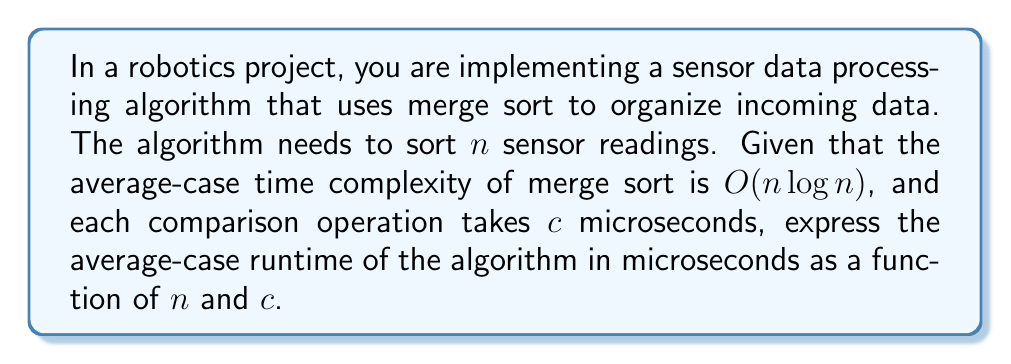Can you answer this question? To solve this problem, we need to follow these steps:

1) Recall that the time complexity $O(n \log n)$ represents the number of comparison operations performed by merge sort in the average case.

2) The actual number of comparisons is approximately $k \cdot n \log n$, where $k$ is a constant factor. For merge sort, $k$ is typically close to 1, so we can assume $k = 1$ for this problem.

3) Each comparison takes $c$ microseconds, so we need to multiply the number of comparisons by $c$.

4) Therefore, the runtime in microseconds can be expressed as:

   $T(n) = c \cdot n \log n$

5) Note that $\log n$ in algorithm analysis typically refers to $\log_2 n$. However, due to the properties of logarithms, we can write this as:

   $T(n) = c \cdot n \ln n / \ln 2$

   where $\ln$ is the natural logarithm.

This formula gives us the average-case runtime of the merge sort algorithm for sorting $n$ sensor readings, where each comparison takes $c$ microseconds.
Answer: $T(n) = c \cdot n \log_2 n$ microseconds, or equivalently, $T(n) = c \cdot n \ln n / \ln 2$ microseconds 